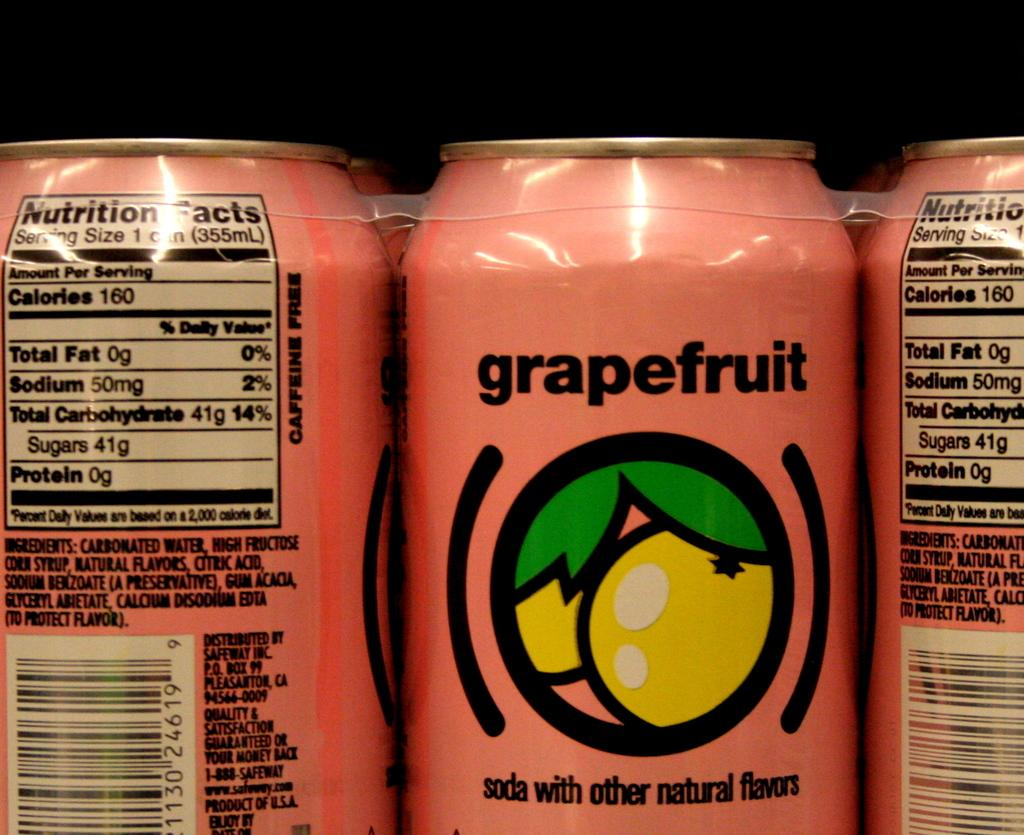<image>
Relay a brief, clear account of the picture shown. A can of grapefruit soda with other natural flavors 